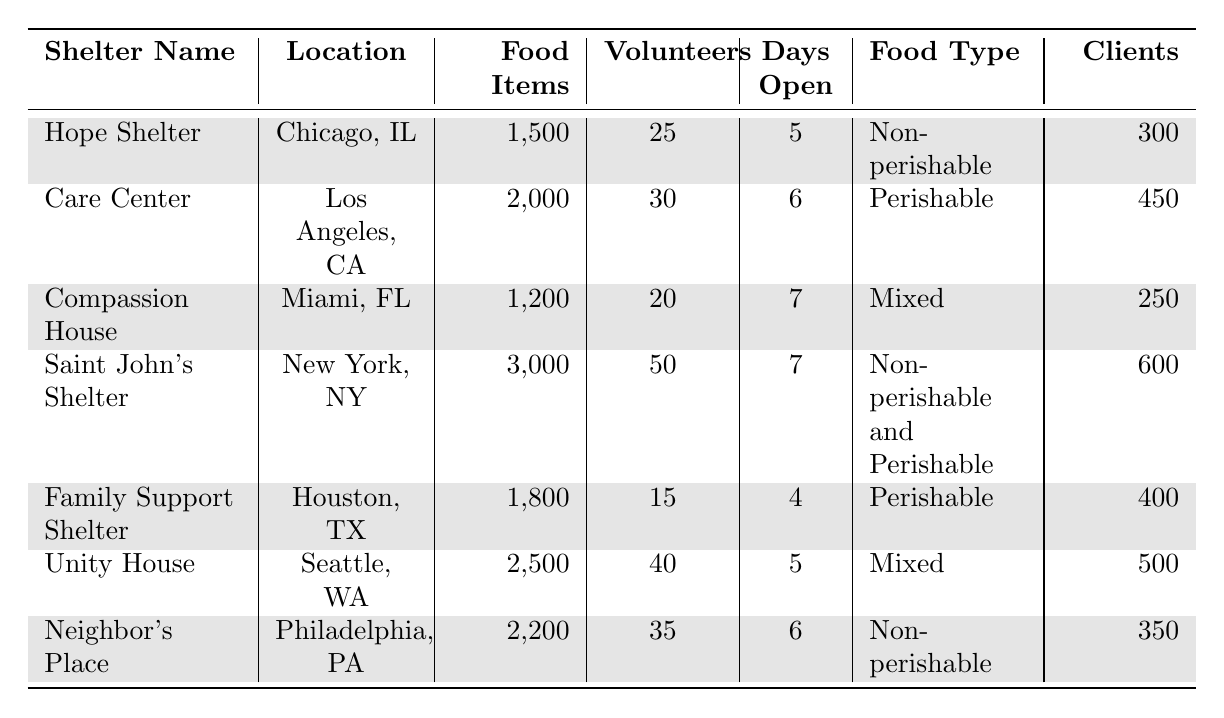What is the total number of food items distributed across all shelters? To find the total, sum the food items distributed by each shelter: 1500 + 2000 + 1200 + 3000 + 1800 + 2500 + 2200 = 13200.
Answer: 13200 Which shelter distributed the highest number of food items? Look at the food items distributed by each shelter and determine the maximum value, which is 3000 from Saint John’s Shelter.
Answer: Saint John’s Shelter How many volunteers were involved at Care Center? The number of volunteers involved at Care Center is directly listed as 30.
Answer: 30 Did Compassion House distribute more food items than Family Support Shelter? Compare the food items distributed: Compassion House distributed 1200 and Family Support Shelter distributed 1800. Since 1200 is less than 1800, the answer is no.
Answer: No What is the average number of clients served by the shelters? To calculate the average, sum the number of clients: 300 + 450 + 250 + 600 + 400 + 500 + 350 = 2850, then divide by the number of shelters (7). Average = 2850 / 7 ≈ 407.14
Answer: 407.14 Which shelter had the least number of volunteers? Compare the number of volunteers across shelters: the minimum is 15 at Family Support Shelter.
Answer: Family Support Shelter Which food type was distributed by the highest number of volunteers? Comparing the volunteers involved for each food type through shelters: Non-perishable and Perishable (Saint John's) had 50 volunteers, which is the highest.
Answer: Non-perishable and Perishable How many more days was Saint John’s Shelter open compared to Family Support Shelter? Saint John’s Shelter was open for 7 days while Family Support Shelter was open for 4 days. The difference is 7 - 4 = 3 days.
Answer: 3 days What percentage of clients were served by Unity House compared to the total clients served across all shelters? First, calculate the total clients: 2850 (derived earlier). Unity House served 500 clients. The percentage is (500 / 2850) * 100 ≈ 17.54%.
Answer: 17.54% Which shelter had the most days open? Check the days open for each shelter: Compassion House and Saint John’s Shelter were open for 7 days, which is the most.
Answer: Compassion House and Saint John’s Shelter 